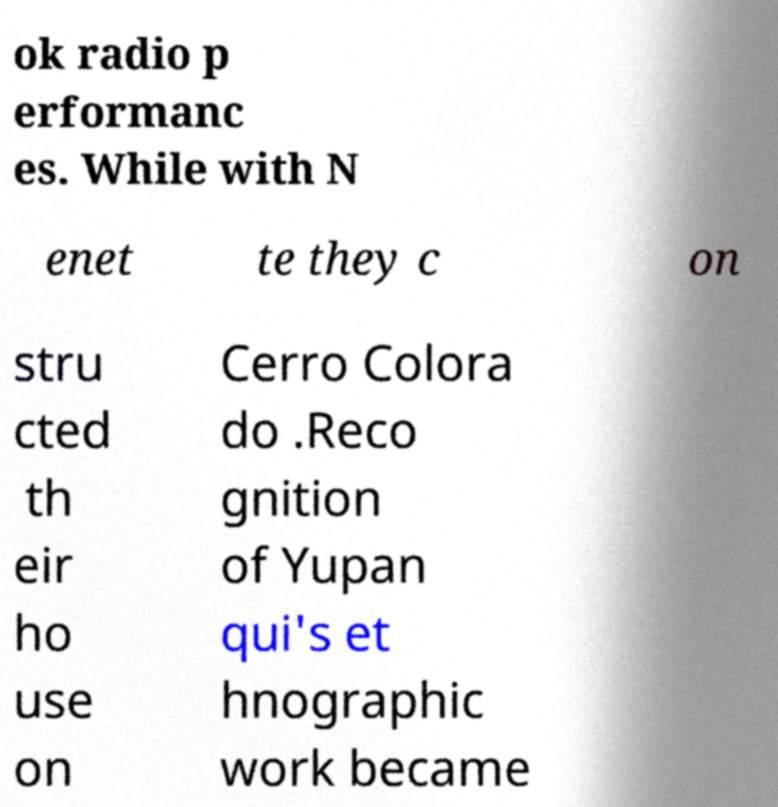Please read and relay the text visible in this image. What does it say? ok radio p erformanc es. While with N enet te they c on stru cted th eir ho use on Cerro Colora do .Reco gnition of Yupan qui's et hnographic work became 